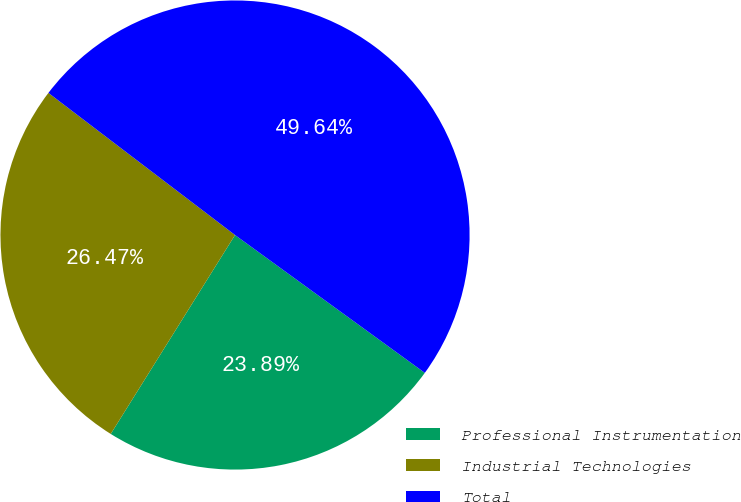Convert chart to OTSL. <chart><loc_0><loc_0><loc_500><loc_500><pie_chart><fcel>Professional Instrumentation<fcel>Industrial Technologies<fcel>Total<nl><fcel>23.89%<fcel>26.47%<fcel>49.64%<nl></chart> 